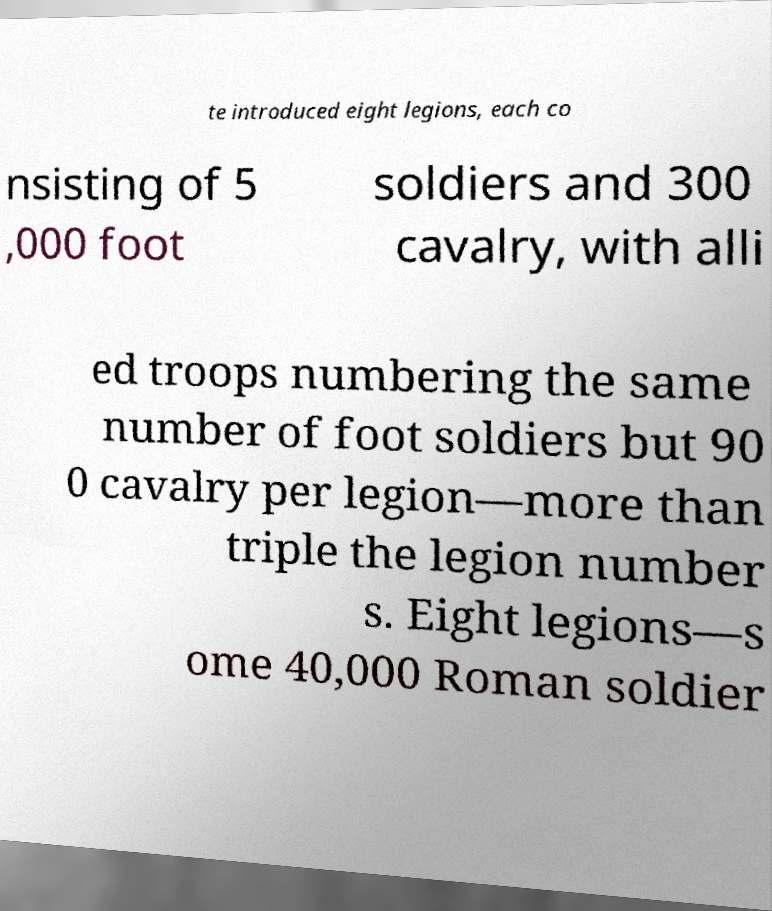I need the written content from this picture converted into text. Can you do that? te introduced eight legions, each co nsisting of 5 ,000 foot soldiers and 300 cavalry, with alli ed troops numbering the same number of foot soldiers but 90 0 cavalry per legion—more than triple the legion number s. Eight legions—s ome 40,000 Roman soldier 